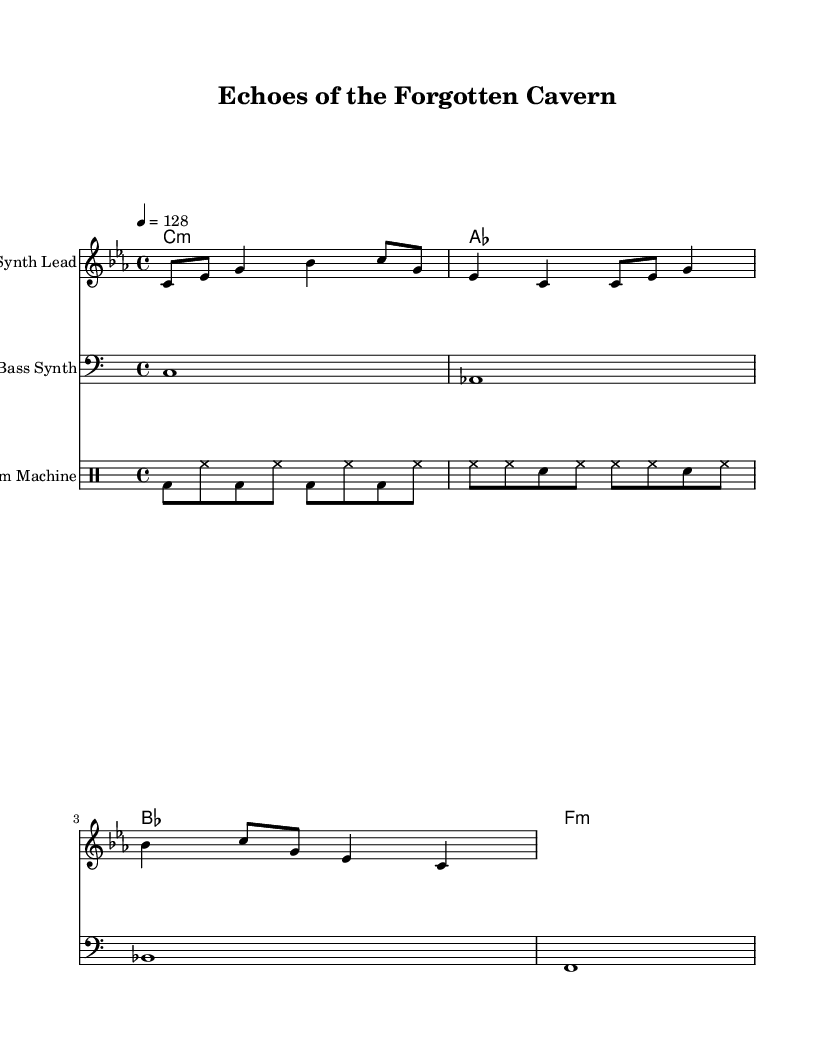What is the key signature of this music? The key signature is C minor, which indicates the presence of three flats (B♭, E♭, and A♭) in the scale.
Answer: C minor What is the time signature of the composition? The time signature is 4/4, meaning there are four beats in each measure and the quarter note receives one beat.
Answer: 4/4 What is the tempo marking of the piece? The tempo marking is quarter note equals 128, indicating that there are 128 quarter note beats per minute.
Answer: 128 How many measures are in the melody? By counting the measures represented in the melody section, there are a total of 2 measures shown.
Answer: 2 What type of instrument is designated for the melody? The score specifies that the melody should be played on a "Synth Lead," indicating an electronic synthesizer sound typical in industrial music.
Answer: Synth Lead What chords are used in the harmony part? The harmony consists of the chords C minor, A flat major, B flat major, and F minor, which are common in ambient and industrial electronic music.
Answer: C minor, A flat, B flat, F minor What percussion instruments are indicated in the score? The score indicates the use of a drum machine, which encompasses bass drum and hi-hat, typical components of electronic music production.
Answer: Drum Machine 